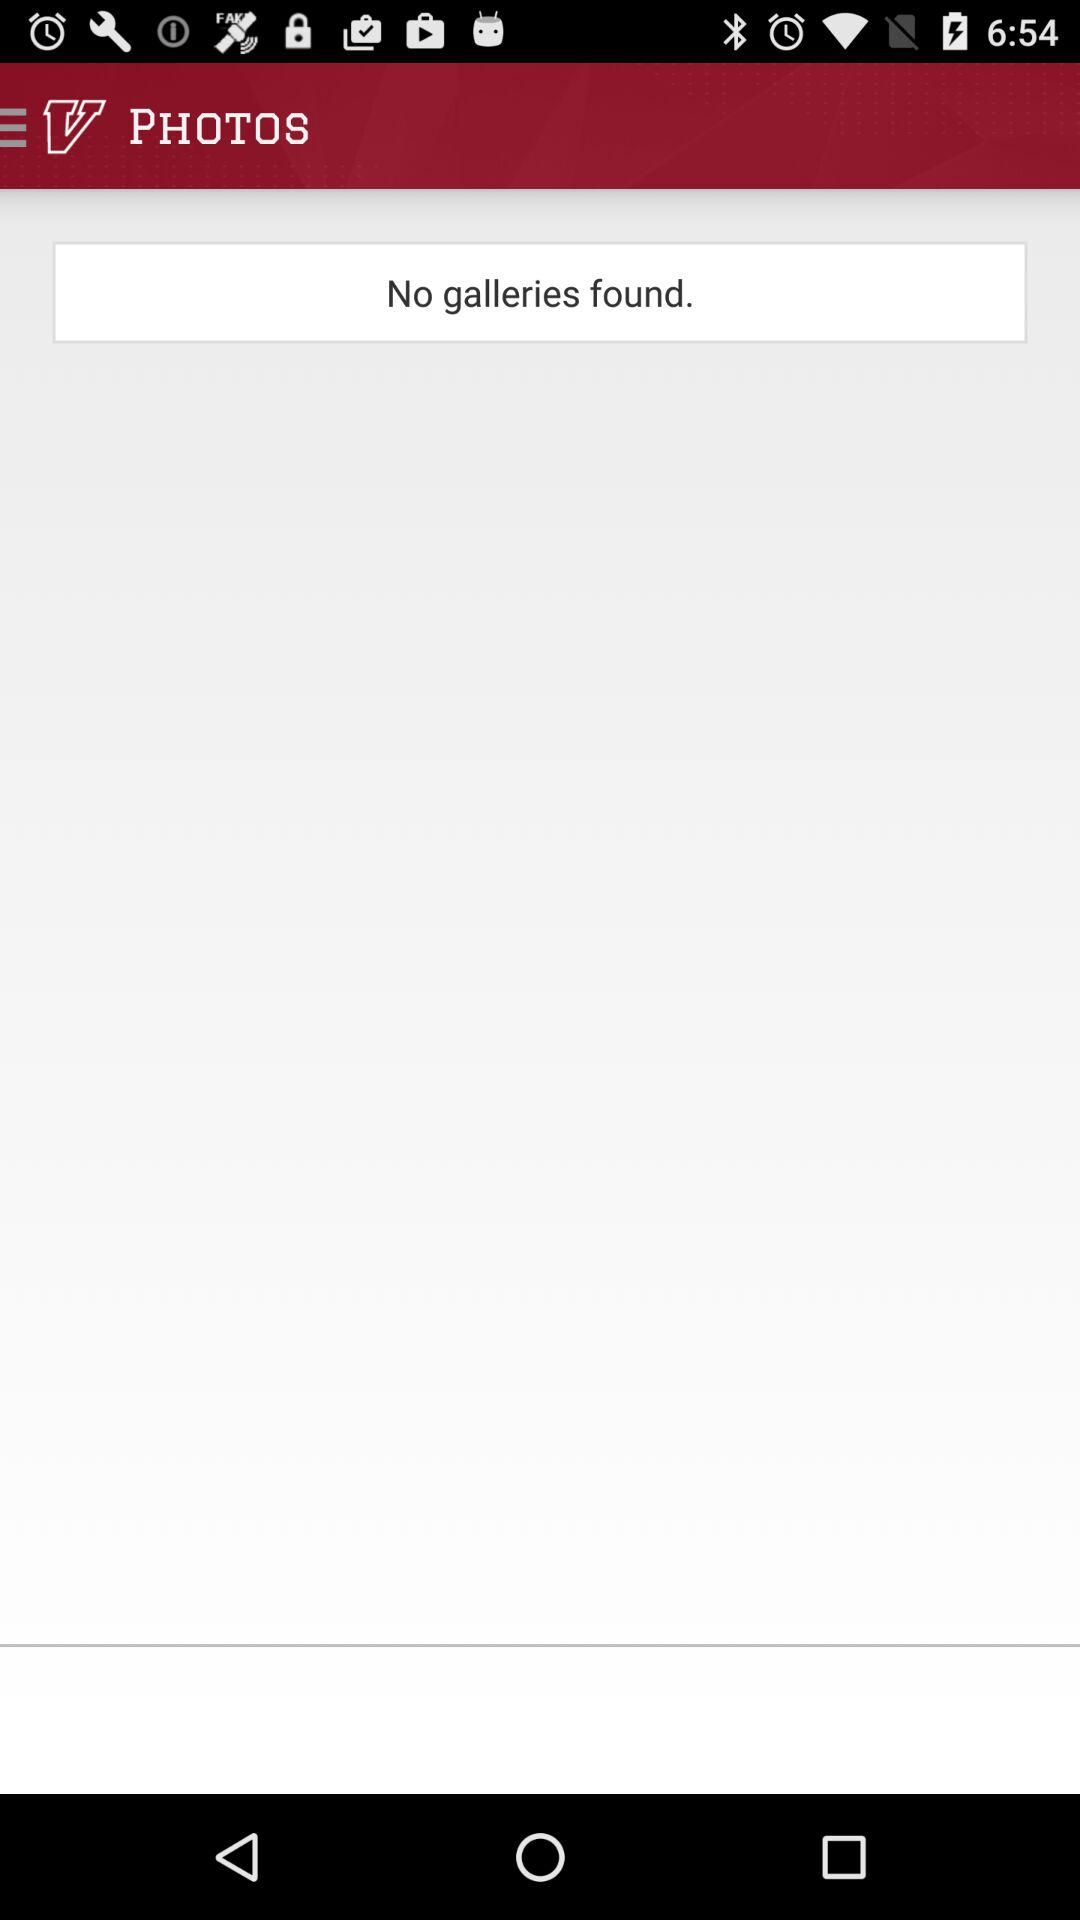What is the application name? The application name is "PHOTOS". 